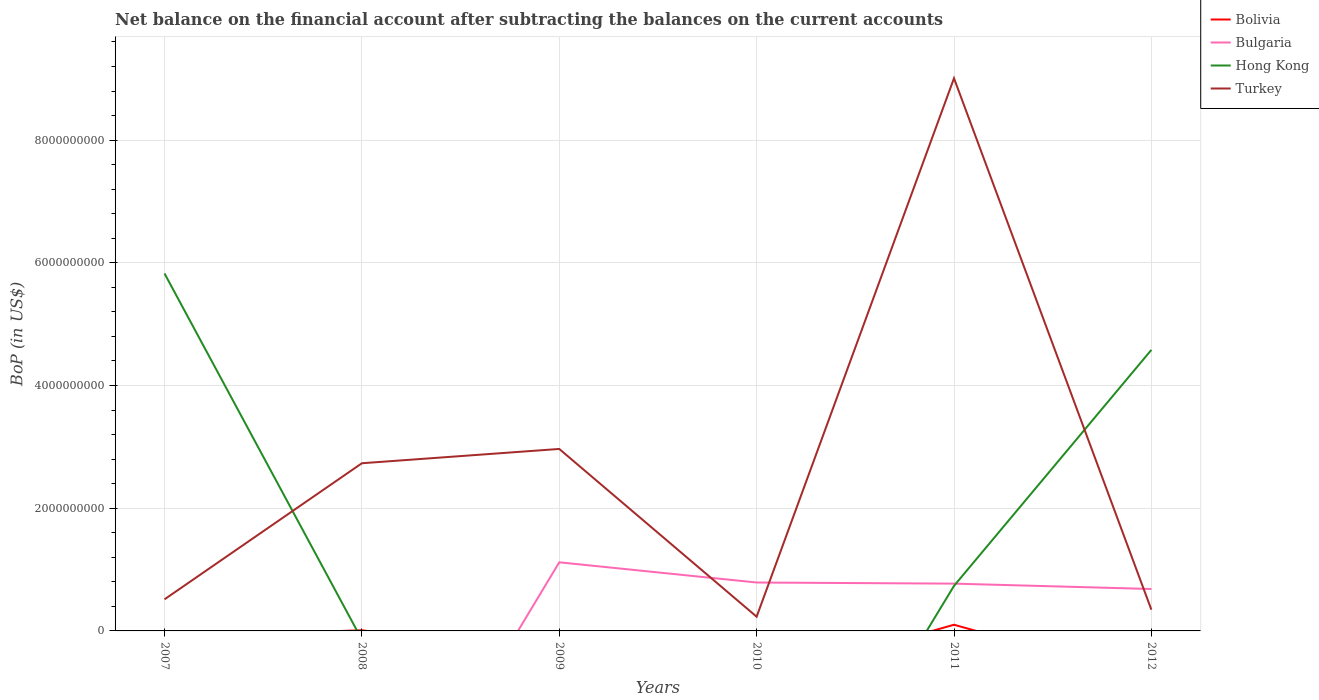Does the line corresponding to Bolivia intersect with the line corresponding to Turkey?
Provide a succinct answer. No. Across all years, what is the maximum Balance of Payments in Bolivia?
Provide a succinct answer. 0. What is the total Balance of Payments in Bulgaria in the graph?
Offer a very short reply. 1.83e+07. What is the difference between the highest and the second highest Balance of Payments in Bulgaria?
Offer a terse response. 1.12e+09. What is the difference between the highest and the lowest Balance of Payments in Hong Kong?
Keep it short and to the point. 2. Is the Balance of Payments in Turkey strictly greater than the Balance of Payments in Hong Kong over the years?
Ensure brevity in your answer.  No. Does the graph contain any zero values?
Give a very brief answer. Yes. Where does the legend appear in the graph?
Provide a short and direct response. Top right. How many legend labels are there?
Make the answer very short. 4. What is the title of the graph?
Offer a terse response. Net balance on the financial account after subtracting the balances on the current accounts. What is the label or title of the X-axis?
Ensure brevity in your answer.  Years. What is the label or title of the Y-axis?
Your answer should be very brief. BoP (in US$). What is the BoP (in US$) of Bolivia in 2007?
Offer a very short reply. 0. What is the BoP (in US$) in Hong Kong in 2007?
Provide a succinct answer. 5.83e+09. What is the BoP (in US$) in Turkey in 2007?
Ensure brevity in your answer.  5.15e+08. What is the BoP (in US$) of Bolivia in 2008?
Offer a terse response. 1.10e+07. What is the BoP (in US$) in Bulgaria in 2008?
Your answer should be very brief. 0. What is the BoP (in US$) of Turkey in 2008?
Offer a terse response. 2.73e+09. What is the BoP (in US$) in Bolivia in 2009?
Keep it short and to the point. 0. What is the BoP (in US$) of Bulgaria in 2009?
Your answer should be compact. 1.12e+09. What is the BoP (in US$) of Turkey in 2009?
Offer a very short reply. 2.97e+09. What is the BoP (in US$) of Bulgaria in 2010?
Offer a very short reply. 7.89e+08. What is the BoP (in US$) of Turkey in 2010?
Provide a succinct answer. 2.32e+08. What is the BoP (in US$) in Bolivia in 2011?
Make the answer very short. 1.01e+08. What is the BoP (in US$) in Bulgaria in 2011?
Ensure brevity in your answer.  7.71e+08. What is the BoP (in US$) in Hong Kong in 2011?
Make the answer very short. 7.34e+08. What is the BoP (in US$) of Turkey in 2011?
Make the answer very short. 9.01e+09. What is the BoP (in US$) in Bolivia in 2012?
Give a very brief answer. 0. What is the BoP (in US$) in Bulgaria in 2012?
Ensure brevity in your answer.  6.83e+08. What is the BoP (in US$) of Hong Kong in 2012?
Keep it short and to the point. 4.58e+09. What is the BoP (in US$) of Turkey in 2012?
Make the answer very short. 3.46e+08. Across all years, what is the maximum BoP (in US$) of Bolivia?
Your response must be concise. 1.01e+08. Across all years, what is the maximum BoP (in US$) of Bulgaria?
Give a very brief answer. 1.12e+09. Across all years, what is the maximum BoP (in US$) in Hong Kong?
Make the answer very short. 5.83e+09. Across all years, what is the maximum BoP (in US$) in Turkey?
Ensure brevity in your answer.  9.01e+09. Across all years, what is the minimum BoP (in US$) of Hong Kong?
Offer a terse response. 0. Across all years, what is the minimum BoP (in US$) in Turkey?
Your response must be concise. 2.32e+08. What is the total BoP (in US$) of Bolivia in the graph?
Offer a very short reply. 1.12e+08. What is the total BoP (in US$) of Bulgaria in the graph?
Your answer should be very brief. 3.36e+09. What is the total BoP (in US$) of Hong Kong in the graph?
Keep it short and to the point. 1.11e+1. What is the total BoP (in US$) of Turkey in the graph?
Give a very brief answer. 1.58e+1. What is the difference between the BoP (in US$) of Turkey in 2007 and that in 2008?
Give a very brief answer. -2.22e+09. What is the difference between the BoP (in US$) in Turkey in 2007 and that in 2009?
Keep it short and to the point. -2.45e+09. What is the difference between the BoP (in US$) of Turkey in 2007 and that in 2010?
Your answer should be compact. 2.83e+08. What is the difference between the BoP (in US$) of Hong Kong in 2007 and that in 2011?
Offer a terse response. 5.09e+09. What is the difference between the BoP (in US$) of Turkey in 2007 and that in 2011?
Make the answer very short. -8.49e+09. What is the difference between the BoP (in US$) of Hong Kong in 2007 and that in 2012?
Keep it short and to the point. 1.24e+09. What is the difference between the BoP (in US$) in Turkey in 2007 and that in 2012?
Offer a terse response. 1.69e+08. What is the difference between the BoP (in US$) in Turkey in 2008 and that in 2009?
Your response must be concise. -2.33e+08. What is the difference between the BoP (in US$) of Turkey in 2008 and that in 2010?
Ensure brevity in your answer.  2.50e+09. What is the difference between the BoP (in US$) in Bolivia in 2008 and that in 2011?
Provide a succinct answer. -8.96e+07. What is the difference between the BoP (in US$) in Turkey in 2008 and that in 2011?
Keep it short and to the point. -6.28e+09. What is the difference between the BoP (in US$) in Turkey in 2008 and that in 2012?
Provide a succinct answer. 2.39e+09. What is the difference between the BoP (in US$) of Bulgaria in 2009 and that in 2010?
Offer a terse response. 3.29e+08. What is the difference between the BoP (in US$) in Turkey in 2009 and that in 2010?
Give a very brief answer. 2.73e+09. What is the difference between the BoP (in US$) of Bulgaria in 2009 and that in 2011?
Keep it short and to the point. 3.48e+08. What is the difference between the BoP (in US$) of Turkey in 2009 and that in 2011?
Offer a terse response. -6.04e+09. What is the difference between the BoP (in US$) of Bulgaria in 2009 and that in 2012?
Offer a very short reply. 4.35e+08. What is the difference between the BoP (in US$) of Turkey in 2009 and that in 2012?
Offer a terse response. 2.62e+09. What is the difference between the BoP (in US$) in Bulgaria in 2010 and that in 2011?
Offer a very short reply. 1.83e+07. What is the difference between the BoP (in US$) of Turkey in 2010 and that in 2011?
Offer a very short reply. -8.78e+09. What is the difference between the BoP (in US$) of Bulgaria in 2010 and that in 2012?
Keep it short and to the point. 1.06e+08. What is the difference between the BoP (in US$) in Turkey in 2010 and that in 2012?
Ensure brevity in your answer.  -1.14e+08. What is the difference between the BoP (in US$) in Bulgaria in 2011 and that in 2012?
Provide a succinct answer. 8.74e+07. What is the difference between the BoP (in US$) of Hong Kong in 2011 and that in 2012?
Provide a succinct answer. -3.85e+09. What is the difference between the BoP (in US$) of Turkey in 2011 and that in 2012?
Your answer should be very brief. 8.66e+09. What is the difference between the BoP (in US$) of Hong Kong in 2007 and the BoP (in US$) of Turkey in 2008?
Make the answer very short. 3.09e+09. What is the difference between the BoP (in US$) of Hong Kong in 2007 and the BoP (in US$) of Turkey in 2009?
Keep it short and to the point. 2.86e+09. What is the difference between the BoP (in US$) in Hong Kong in 2007 and the BoP (in US$) in Turkey in 2010?
Your answer should be compact. 5.59e+09. What is the difference between the BoP (in US$) of Hong Kong in 2007 and the BoP (in US$) of Turkey in 2011?
Your answer should be very brief. -3.18e+09. What is the difference between the BoP (in US$) in Hong Kong in 2007 and the BoP (in US$) in Turkey in 2012?
Your answer should be very brief. 5.48e+09. What is the difference between the BoP (in US$) of Bolivia in 2008 and the BoP (in US$) of Bulgaria in 2009?
Your answer should be very brief. -1.11e+09. What is the difference between the BoP (in US$) of Bolivia in 2008 and the BoP (in US$) of Turkey in 2009?
Provide a short and direct response. -2.95e+09. What is the difference between the BoP (in US$) in Bolivia in 2008 and the BoP (in US$) in Bulgaria in 2010?
Give a very brief answer. -7.78e+08. What is the difference between the BoP (in US$) in Bolivia in 2008 and the BoP (in US$) in Turkey in 2010?
Your response must be concise. -2.21e+08. What is the difference between the BoP (in US$) in Bolivia in 2008 and the BoP (in US$) in Bulgaria in 2011?
Make the answer very short. -7.60e+08. What is the difference between the BoP (in US$) of Bolivia in 2008 and the BoP (in US$) of Hong Kong in 2011?
Ensure brevity in your answer.  -7.23e+08. What is the difference between the BoP (in US$) of Bolivia in 2008 and the BoP (in US$) of Turkey in 2011?
Provide a short and direct response. -9.00e+09. What is the difference between the BoP (in US$) in Bolivia in 2008 and the BoP (in US$) in Bulgaria in 2012?
Your answer should be very brief. -6.72e+08. What is the difference between the BoP (in US$) of Bolivia in 2008 and the BoP (in US$) of Hong Kong in 2012?
Ensure brevity in your answer.  -4.57e+09. What is the difference between the BoP (in US$) in Bolivia in 2008 and the BoP (in US$) in Turkey in 2012?
Offer a very short reply. -3.35e+08. What is the difference between the BoP (in US$) in Bulgaria in 2009 and the BoP (in US$) in Turkey in 2010?
Keep it short and to the point. 8.86e+08. What is the difference between the BoP (in US$) of Bulgaria in 2009 and the BoP (in US$) of Hong Kong in 2011?
Keep it short and to the point. 3.84e+08. What is the difference between the BoP (in US$) in Bulgaria in 2009 and the BoP (in US$) in Turkey in 2011?
Offer a terse response. -7.89e+09. What is the difference between the BoP (in US$) in Bulgaria in 2009 and the BoP (in US$) in Hong Kong in 2012?
Ensure brevity in your answer.  -3.46e+09. What is the difference between the BoP (in US$) of Bulgaria in 2009 and the BoP (in US$) of Turkey in 2012?
Make the answer very short. 7.72e+08. What is the difference between the BoP (in US$) in Bulgaria in 2010 and the BoP (in US$) in Hong Kong in 2011?
Keep it short and to the point. 5.46e+07. What is the difference between the BoP (in US$) of Bulgaria in 2010 and the BoP (in US$) of Turkey in 2011?
Make the answer very short. -8.22e+09. What is the difference between the BoP (in US$) in Bulgaria in 2010 and the BoP (in US$) in Hong Kong in 2012?
Your answer should be very brief. -3.79e+09. What is the difference between the BoP (in US$) in Bulgaria in 2010 and the BoP (in US$) in Turkey in 2012?
Ensure brevity in your answer.  4.43e+08. What is the difference between the BoP (in US$) in Bolivia in 2011 and the BoP (in US$) in Bulgaria in 2012?
Your answer should be very brief. -5.83e+08. What is the difference between the BoP (in US$) in Bolivia in 2011 and the BoP (in US$) in Hong Kong in 2012?
Your response must be concise. -4.48e+09. What is the difference between the BoP (in US$) of Bolivia in 2011 and the BoP (in US$) of Turkey in 2012?
Offer a terse response. -2.45e+08. What is the difference between the BoP (in US$) in Bulgaria in 2011 and the BoP (in US$) in Hong Kong in 2012?
Ensure brevity in your answer.  -3.81e+09. What is the difference between the BoP (in US$) in Bulgaria in 2011 and the BoP (in US$) in Turkey in 2012?
Your response must be concise. 4.25e+08. What is the difference between the BoP (in US$) of Hong Kong in 2011 and the BoP (in US$) of Turkey in 2012?
Your response must be concise. 3.88e+08. What is the average BoP (in US$) in Bolivia per year?
Provide a succinct answer. 1.86e+07. What is the average BoP (in US$) in Bulgaria per year?
Ensure brevity in your answer.  5.60e+08. What is the average BoP (in US$) of Hong Kong per year?
Give a very brief answer. 1.86e+09. What is the average BoP (in US$) in Turkey per year?
Your answer should be compact. 2.63e+09. In the year 2007, what is the difference between the BoP (in US$) of Hong Kong and BoP (in US$) of Turkey?
Give a very brief answer. 5.31e+09. In the year 2008, what is the difference between the BoP (in US$) in Bolivia and BoP (in US$) in Turkey?
Offer a terse response. -2.72e+09. In the year 2009, what is the difference between the BoP (in US$) of Bulgaria and BoP (in US$) of Turkey?
Give a very brief answer. -1.85e+09. In the year 2010, what is the difference between the BoP (in US$) in Bulgaria and BoP (in US$) in Turkey?
Your answer should be compact. 5.57e+08. In the year 2011, what is the difference between the BoP (in US$) of Bolivia and BoP (in US$) of Bulgaria?
Give a very brief answer. -6.70e+08. In the year 2011, what is the difference between the BoP (in US$) in Bolivia and BoP (in US$) in Hong Kong?
Provide a succinct answer. -6.34e+08. In the year 2011, what is the difference between the BoP (in US$) in Bolivia and BoP (in US$) in Turkey?
Your answer should be very brief. -8.91e+09. In the year 2011, what is the difference between the BoP (in US$) of Bulgaria and BoP (in US$) of Hong Kong?
Make the answer very short. 3.63e+07. In the year 2011, what is the difference between the BoP (in US$) of Bulgaria and BoP (in US$) of Turkey?
Provide a succinct answer. -8.24e+09. In the year 2011, what is the difference between the BoP (in US$) of Hong Kong and BoP (in US$) of Turkey?
Ensure brevity in your answer.  -8.27e+09. In the year 2012, what is the difference between the BoP (in US$) of Bulgaria and BoP (in US$) of Hong Kong?
Make the answer very short. -3.90e+09. In the year 2012, what is the difference between the BoP (in US$) of Bulgaria and BoP (in US$) of Turkey?
Provide a short and direct response. 3.37e+08. In the year 2012, what is the difference between the BoP (in US$) of Hong Kong and BoP (in US$) of Turkey?
Keep it short and to the point. 4.23e+09. What is the ratio of the BoP (in US$) in Turkey in 2007 to that in 2008?
Offer a very short reply. 0.19. What is the ratio of the BoP (in US$) in Turkey in 2007 to that in 2009?
Provide a succinct answer. 0.17. What is the ratio of the BoP (in US$) of Turkey in 2007 to that in 2010?
Offer a terse response. 2.22. What is the ratio of the BoP (in US$) in Hong Kong in 2007 to that in 2011?
Ensure brevity in your answer.  7.93. What is the ratio of the BoP (in US$) of Turkey in 2007 to that in 2011?
Your answer should be compact. 0.06. What is the ratio of the BoP (in US$) in Hong Kong in 2007 to that in 2012?
Offer a very short reply. 1.27. What is the ratio of the BoP (in US$) in Turkey in 2007 to that in 2012?
Your response must be concise. 1.49. What is the ratio of the BoP (in US$) of Turkey in 2008 to that in 2009?
Your answer should be very brief. 0.92. What is the ratio of the BoP (in US$) of Turkey in 2008 to that in 2010?
Offer a very short reply. 11.78. What is the ratio of the BoP (in US$) of Bolivia in 2008 to that in 2011?
Provide a short and direct response. 0.11. What is the ratio of the BoP (in US$) of Turkey in 2008 to that in 2011?
Provide a succinct answer. 0.3. What is the ratio of the BoP (in US$) in Turkey in 2008 to that in 2012?
Give a very brief answer. 7.9. What is the ratio of the BoP (in US$) of Bulgaria in 2009 to that in 2010?
Provide a short and direct response. 1.42. What is the ratio of the BoP (in US$) in Turkey in 2009 to that in 2010?
Offer a terse response. 12.78. What is the ratio of the BoP (in US$) of Bulgaria in 2009 to that in 2011?
Provide a succinct answer. 1.45. What is the ratio of the BoP (in US$) of Turkey in 2009 to that in 2011?
Provide a succinct answer. 0.33. What is the ratio of the BoP (in US$) of Bulgaria in 2009 to that in 2012?
Make the answer very short. 1.64. What is the ratio of the BoP (in US$) in Turkey in 2009 to that in 2012?
Offer a terse response. 8.57. What is the ratio of the BoP (in US$) in Bulgaria in 2010 to that in 2011?
Provide a short and direct response. 1.02. What is the ratio of the BoP (in US$) of Turkey in 2010 to that in 2011?
Provide a short and direct response. 0.03. What is the ratio of the BoP (in US$) in Bulgaria in 2010 to that in 2012?
Provide a short and direct response. 1.15. What is the ratio of the BoP (in US$) in Turkey in 2010 to that in 2012?
Offer a terse response. 0.67. What is the ratio of the BoP (in US$) of Bulgaria in 2011 to that in 2012?
Your answer should be compact. 1.13. What is the ratio of the BoP (in US$) of Hong Kong in 2011 to that in 2012?
Ensure brevity in your answer.  0.16. What is the ratio of the BoP (in US$) in Turkey in 2011 to that in 2012?
Keep it short and to the point. 26.03. What is the difference between the highest and the second highest BoP (in US$) in Bulgaria?
Offer a terse response. 3.29e+08. What is the difference between the highest and the second highest BoP (in US$) in Hong Kong?
Provide a short and direct response. 1.24e+09. What is the difference between the highest and the second highest BoP (in US$) in Turkey?
Offer a terse response. 6.04e+09. What is the difference between the highest and the lowest BoP (in US$) in Bolivia?
Provide a short and direct response. 1.01e+08. What is the difference between the highest and the lowest BoP (in US$) of Bulgaria?
Keep it short and to the point. 1.12e+09. What is the difference between the highest and the lowest BoP (in US$) in Hong Kong?
Your answer should be very brief. 5.83e+09. What is the difference between the highest and the lowest BoP (in US$) in Turkey?
Give a very brief answer. 8.78e+09. 